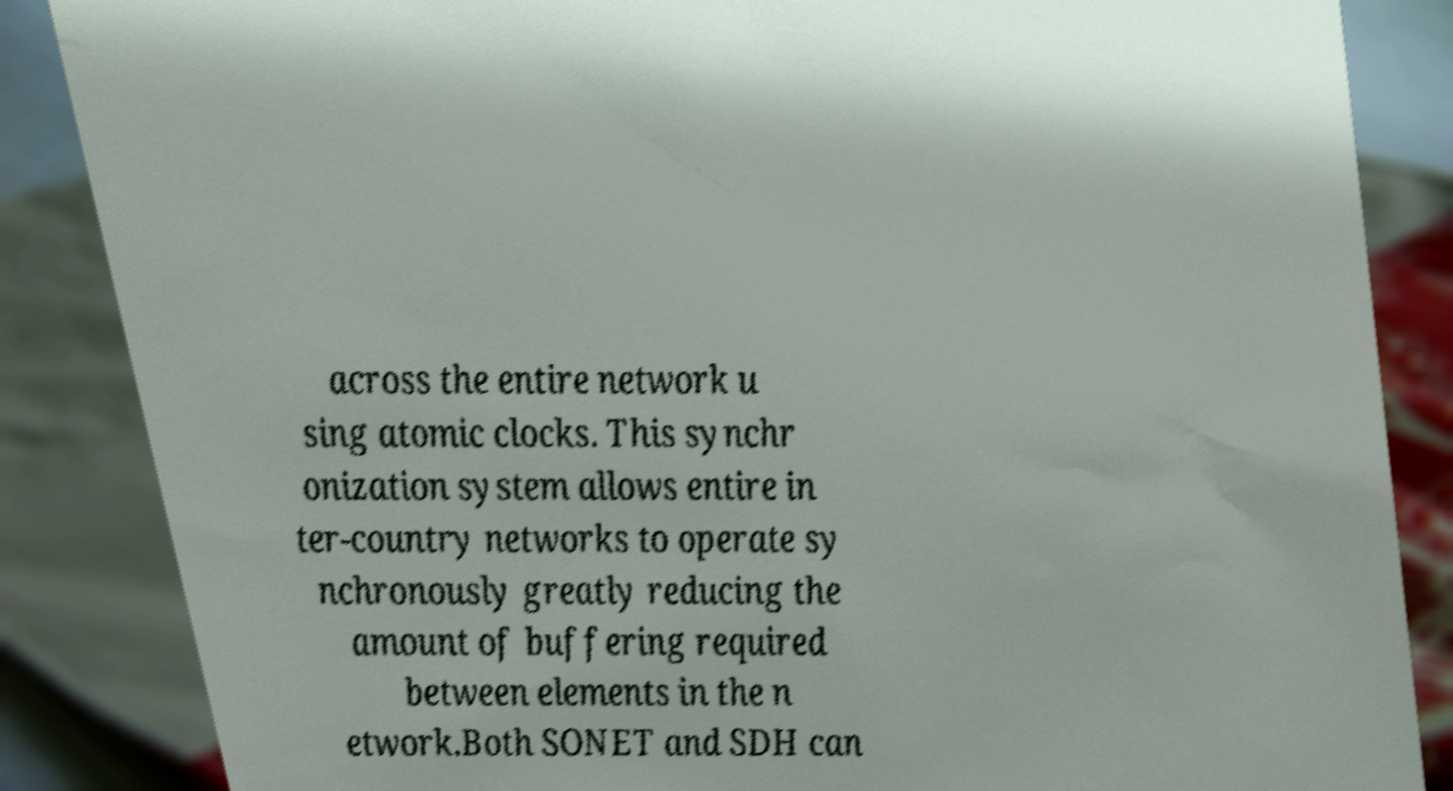I need the written content from this picture converted into text. Can you do that? across the entire network u sing atomic clocks. This synchr onization system allows entire in ter-country networks to operate sy nchronously greatly reducing the amount of buffering required between elements in the n etwork.Both SONET and SDH can 